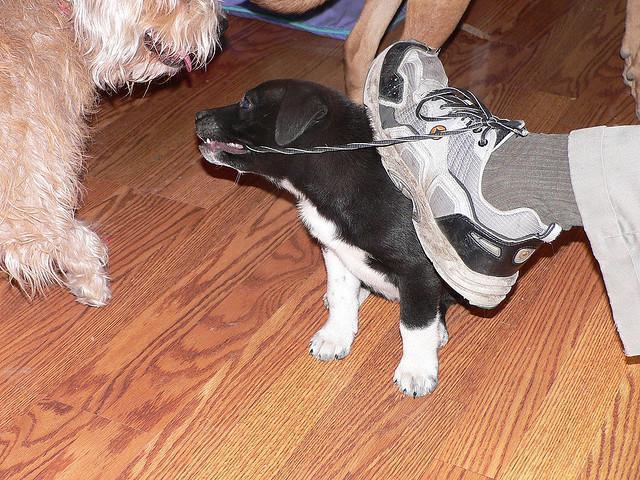How many dogs are there?
Give a very brief answer. 2. 